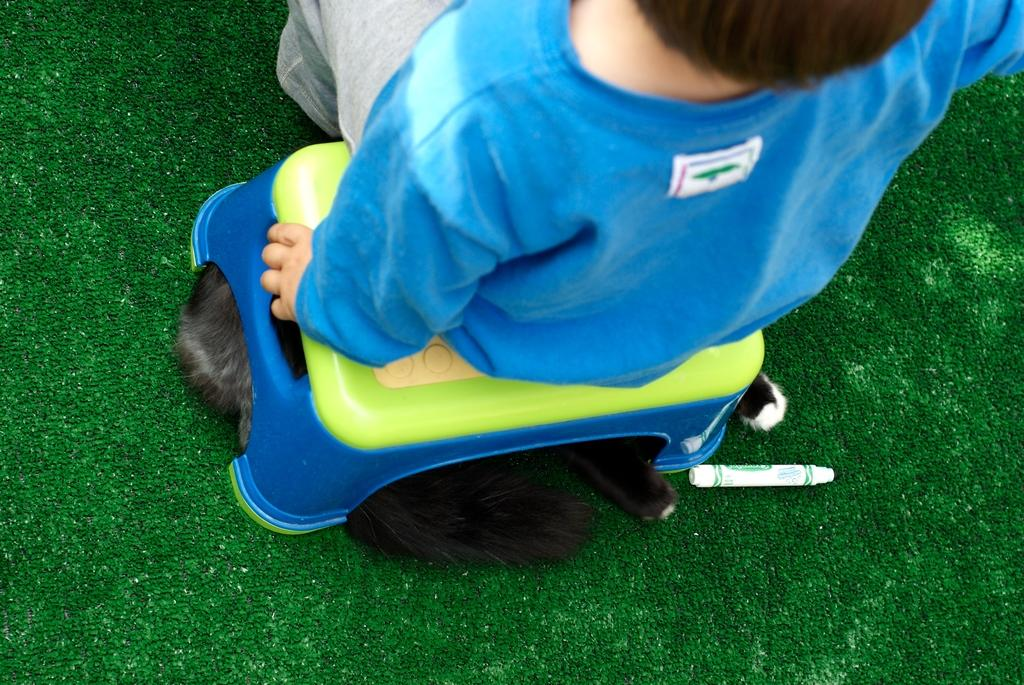What is the main subject of the image? The main subject of the image is a kid. What is the kid doing in the image? The kid is sitting on a stool. Is there any other object or animal in the image? Yes, there is an animal lying under the stool. Can you describe the kid's clothing? The kid is wearing a blue T-shirt. What else can be seen on the floor in the image? There is a marker on the carpet. How many sisters does the kid have in the image? There is no information about the kid's sisters in the image. What type of destruction is the animal causing under the stool? There is no destruction or any indication of the animal causing any harm in the image. 